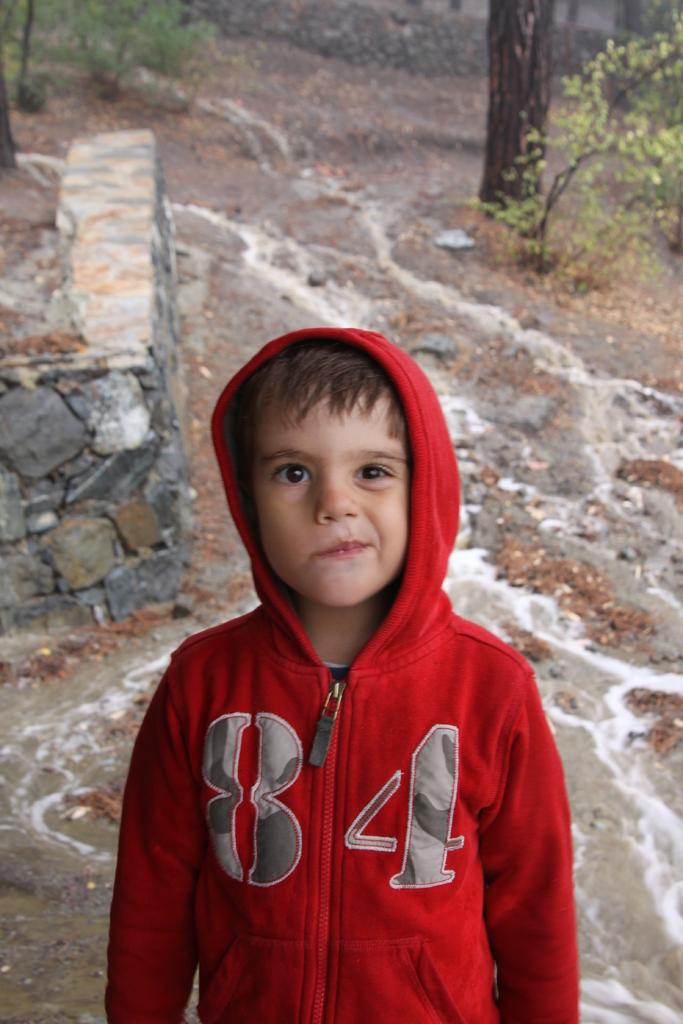<image>
Summarize the visual content of the image. Little boy making a face and wearing a red sweatshirt with the number 84 in camo. 